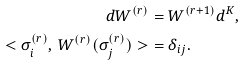Convert formula to latex. <formula><loc_0><loc_0><loc_500><loc_500>d W ^ { ( r ) } & = W ^ { ( r + 1 ) } d ^ { K } , \\ < \sigma ^ { ( r ) } _ { i } , \, W ^ { ( r ) } ( \sigma ^ { ( r ) } _ { j } ) > & = \delta _ { i j } .</formula> 